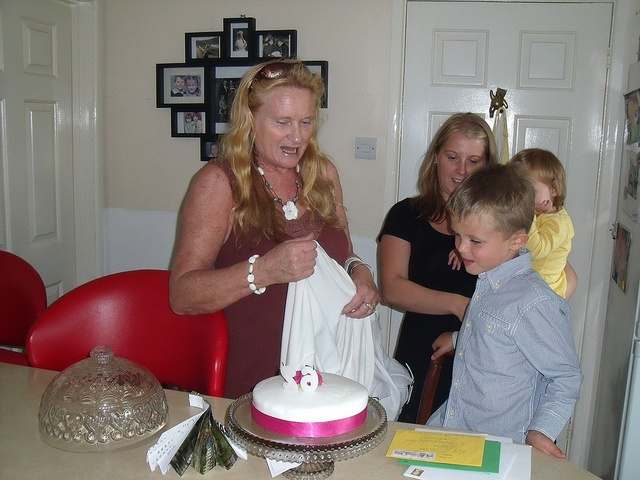Describe the objects in this image and their specific colors. I can see dining table in gray, lightgray, and darkgray tones, people in gray, maroon, and brown tones, people in gray and darkgray tones, people in gray, black, brown, and maroon tones, and chair in gray, maroon, and brown tones in this image. 